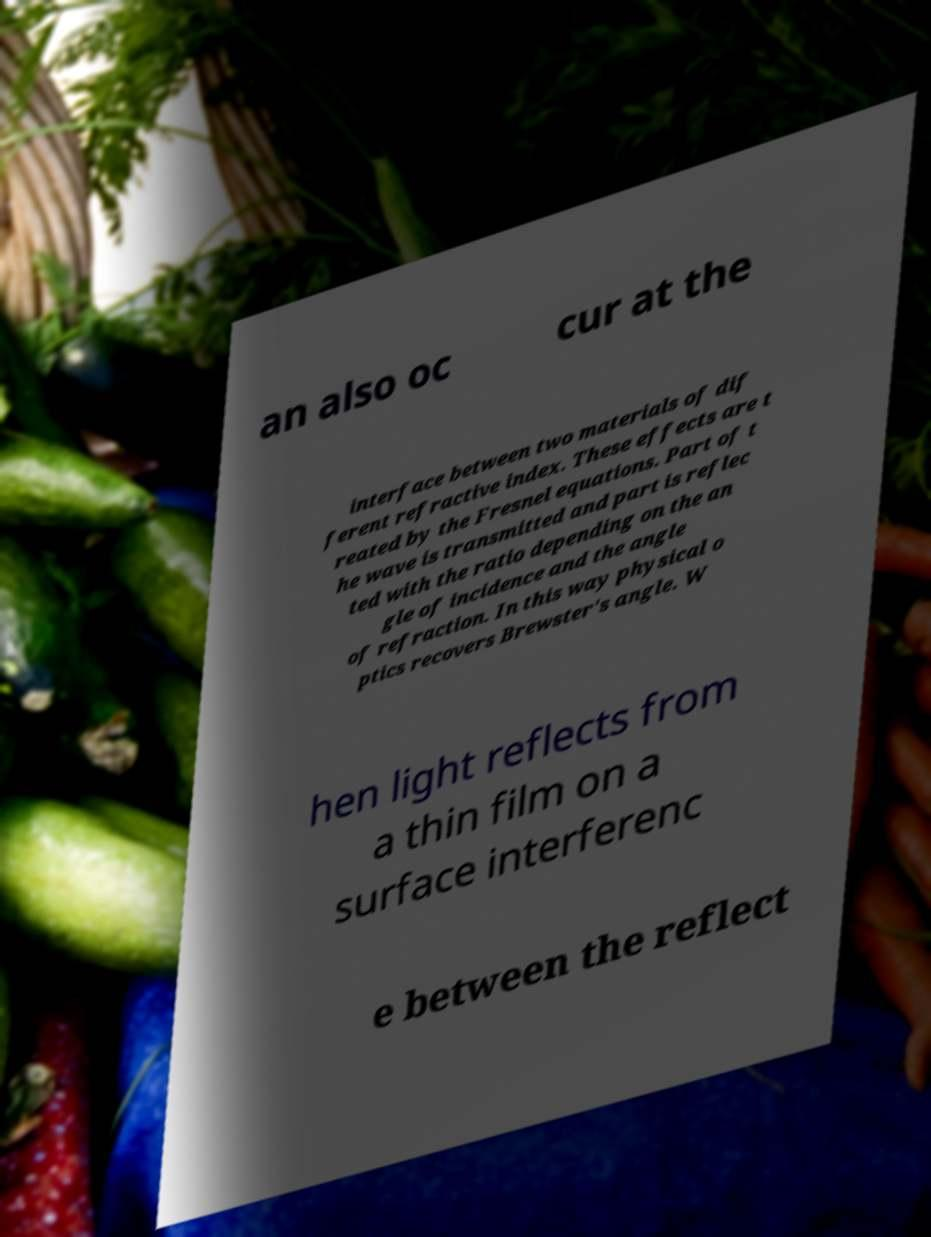Could you assist in decoding the text presented in this image and type it out clearly? an also oc cur at the interface between two materials of dif ferent refractive index. These effects are t reated by the Fresnel equations. Part of t he wave is transmitted and part is reflec ted with the ratio depending on the an gle of incidence and the angle of refraction. In this way physical o ptics recovers Brewster's angle. W hen light reflects from a thin film on a surface interferenc e between the reflect 